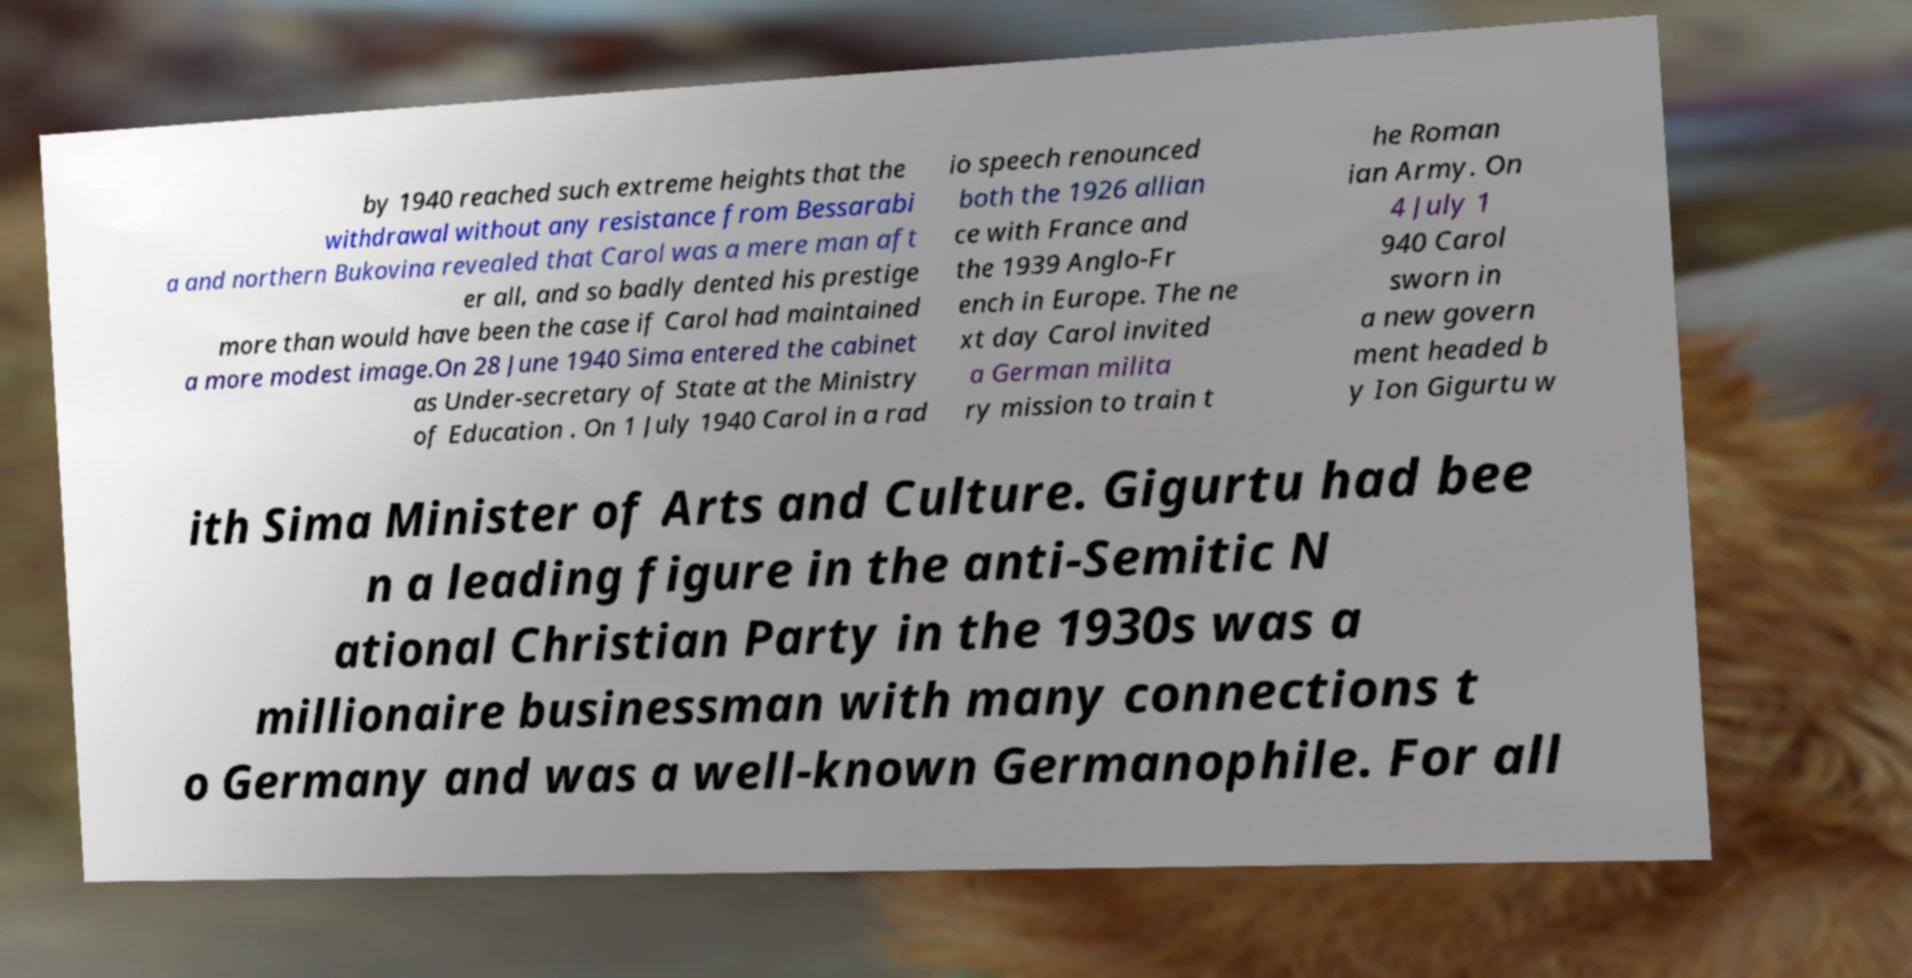What messages or text are displayed in this image? I need them in a readable, typed format. by 1940 reached such extreme heights that the withdrawal without any resistance from Bessarabi a and northern Bukovina revealed that Carol was a mere man aft er all, and so badly dented his prestige more than would have been the case if Carol had maintained a more modest image.On 28 June 1940 Sima entered the cabinet as Under-secretary of State at the Ministry of Education . On 1 July 1940 Carol in a rad io speech renounced both the 1926 allian ce with France and the 1939 Anglo-Fr ench in Europe. The ne xt day Carol invited a German milita ry mission to train t he Roman ian Army. On 4 July 1 940 Carol sworn in a new govern ment headed b y Ion Gigurtu w ith Sima Minister of Arts and Culture. Gigurtu had bee n a leading figure in the anti-Semitic N ational Christian Party in the 1930s was a millionaire businessman with many connections t o Germany and was a well-known Germanophile. For all 